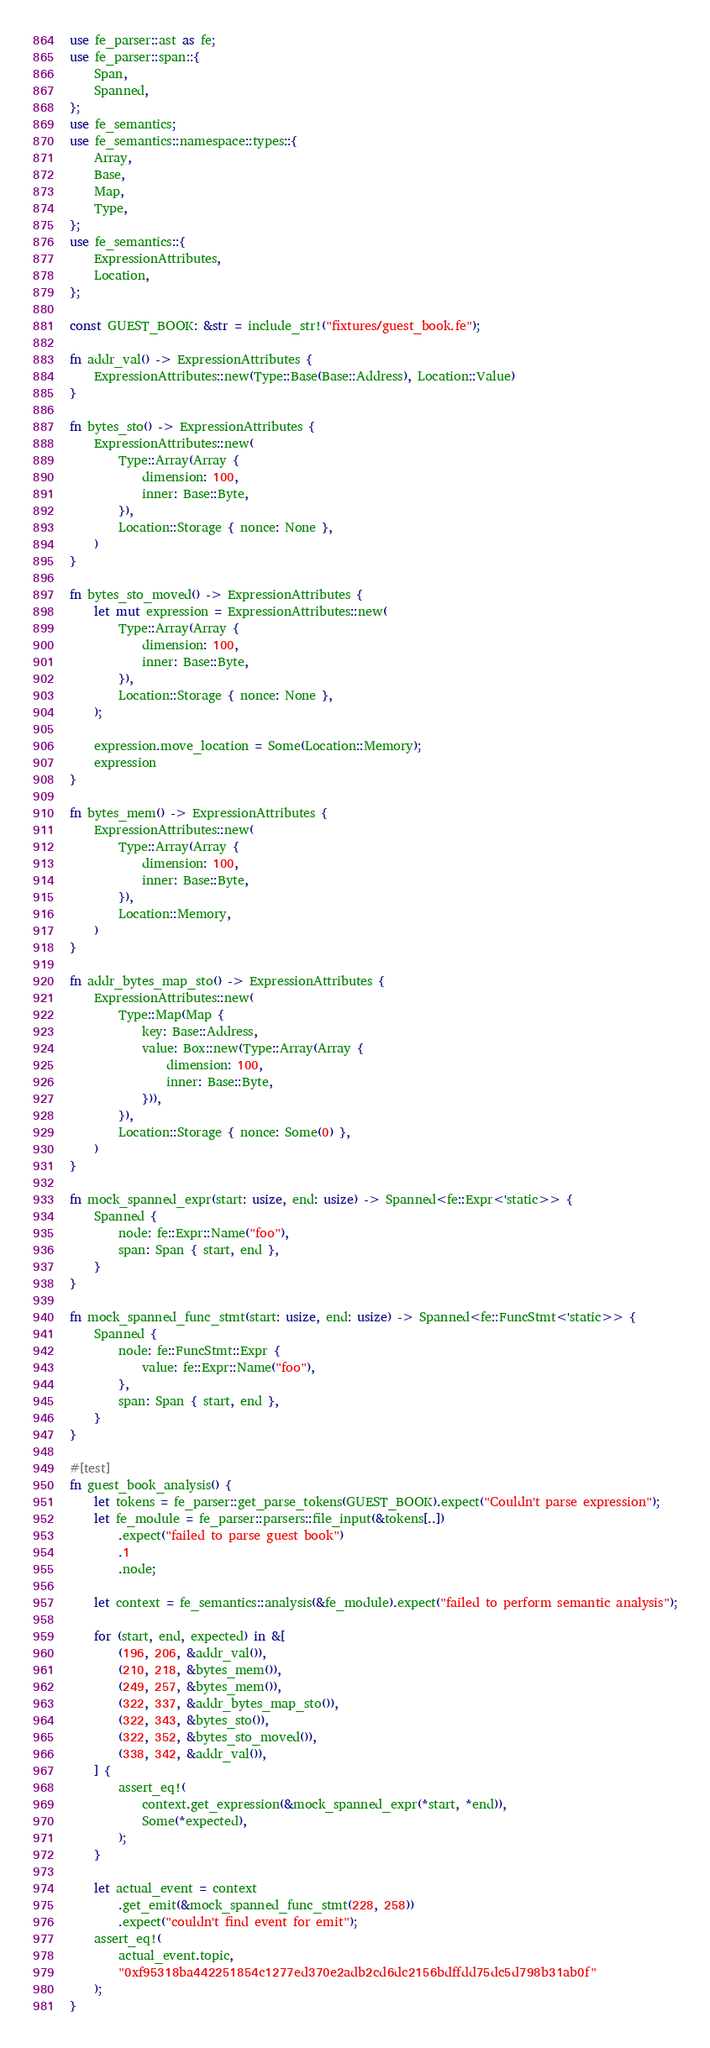Convert code to text. <code><loc_0><loc_0><loc_500><loc_500><_Rust_>use fe_parser::ast as fe;
use fe_parser::span::{
    Span,
    Spanned,
};
use fe_semantics;
use fe_semantics::namespace::types::{
    Array,
    Base,
    Map,
    Type,
};
use fe_semantics::{
    ExpressionAttributes,
    Location,
};

const GUEST_BOOK: &str = include_str!("fixtures/guest_book.fe");

fn addr_val() -> ExpressionAttributes {
    ExpressionAttributes::new(Type::Base(Base::Address), Location::Value)
}

fn bytes_sto() -> ExpressionAttributes {
    ExpressionAttributes::new(
        Type::Array(Array {
            dimension: 100,
            inner: Base::Byte,
        }),
        Location::Storage { nonce: None },
    )
}

fn bytes_sto_moved() -> ExpressionAttributes {
    let mut expression = ExpressionAttributes::new(
        Type::Array(Array {
            dimension: 100,
            inner: Base::Byte,
        }),
        Location::Storage { nonce: None },
    );

    expression.move_location = Some(Location::Memory);
    expression
}

fn bytes_mem() -> ExpressionAttributes {
    ExpressionAttributes::new(
        Type::Array(Array {
            dimension: 100,
            inner: Base::Byte,
        }),
        Location::Memory,
    )
}

fn addr_bytes_map_sto() -> ExpressionAttributes {
    ExpressionAttributes::new(
        Type::Map(Map {
            key: Base::Address,
            value: Box::new(Type::Array(Array {
                dimension: 100,
                inner: Base::Byte,
            })),
        }),
        Location::Storage { nonce: Some(0) },
    )
}

fn mock_spanned_expr(start: usize, end: usize) -> Spanned<fe::Expr<'static>> {
    Spanned {
        node: fe::Expr::Name("foo"),
        span: Span { start, end },
    }
}

fn mock_spanned_func_stmt(start: usize, end: usize) -> Spanned<fe::FuncStmt<'static>> {
    Spanned {
        node: fe::FuncStmt::Expr {
            value: fe::Expr::Name("foo"),
        },
        span: Span { start, end },
    }
}

#[test]
fn guest_book_analysis() {
    let tokens = fe_parser::get_parse_tokens(GUEST_BOOK).expect("Couldn't parse expression");
    let fe_module = fe_parser::parsers::file_input(&tokens[..])
        .expect("failed to parse guest book")
        .1
        .node;

    let context = fe_semantics::analysis(&fe_module).expect("failed to perform semantic analysis");

    for (start, end, expected) in &[
        (196, 206, &addr_val()),
        (210, 218, &bytes_mem()),
        (249, 257, &bytes_mem()),
        (322, 337, &addr_bytes_map_sto()),
        (322, 343, &bytes_sto()),
        (322, 352, &bytes_sto_moved()),
        (338, 342, &addr_val()),
    ] {
        assert_eq!(
            context.get_expression(&mock_spanned_expr(*start, *end)),
            Some(*expected),
        );
    }

    let actual_event = context
        .get_emit(&mock_spanned_func_stmt(228, 258))
        .expect("couldn't find event for emit");
    assert_eq!(
        actual_event.topic,
        "0xf95318ba442251854c1277ed370e2adb2cd6dc2156bdffdd75dc5d798b31ab0f"
    );
}
</code> 